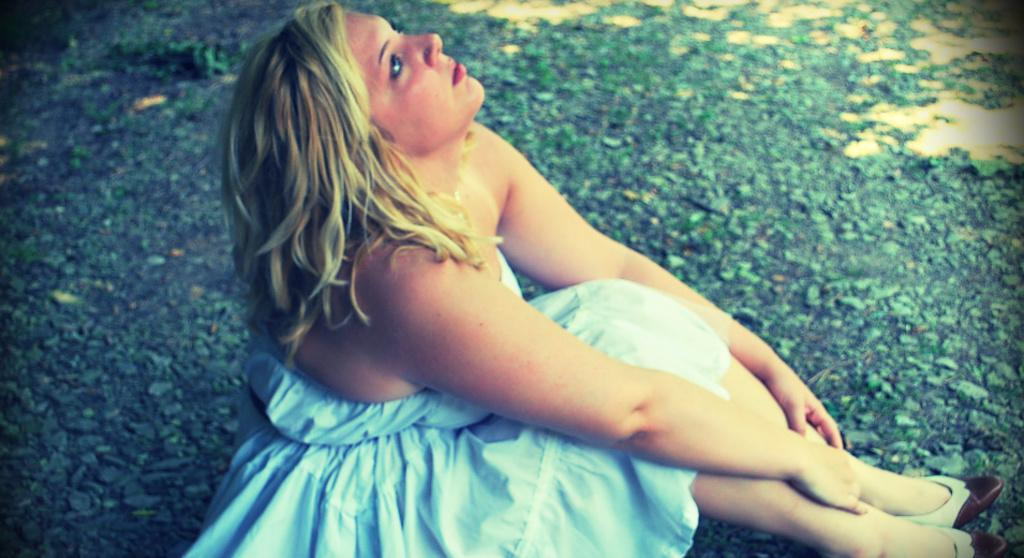Who is the main subject in the image? There is a woman in the image. What is the woman wearing? The woman is wearing a white dress. What is the woman's position in the image? The woman is sitting on the ground. How does the woman's feeling of happiness affect her digestion in the image? There is no indication of the woman's feelings or digestion in the image, as it only shows her sitting on the ground wearing a white dress. 